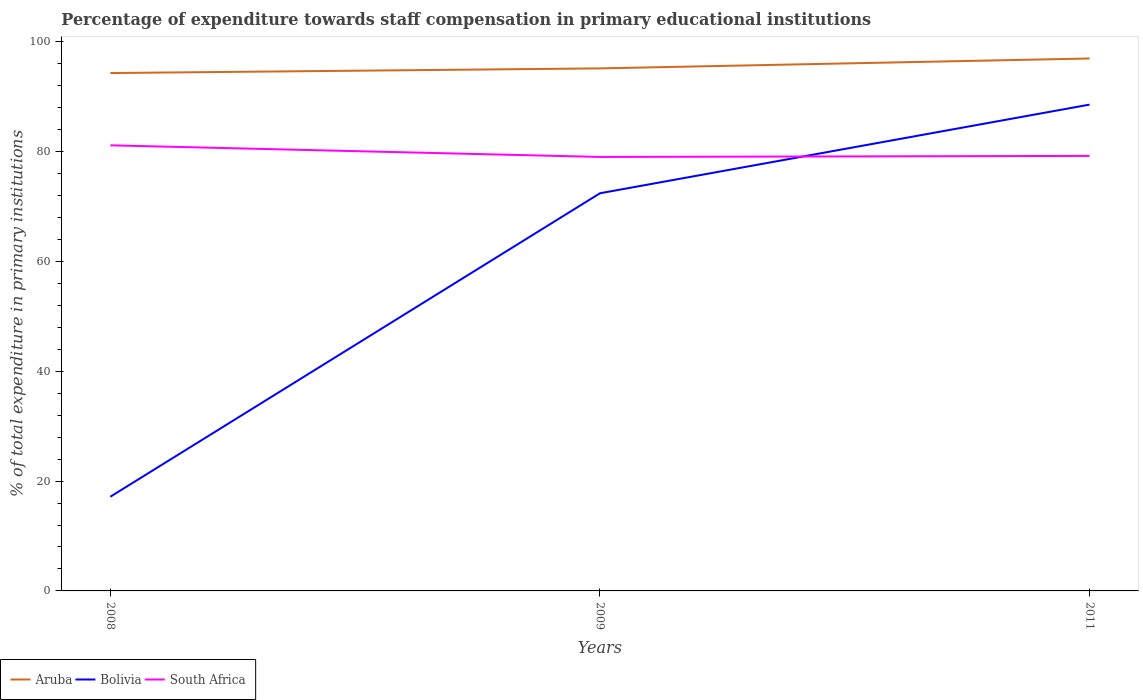How many different coloured lines are there?
Provide a succinct answer. 3. Across all years, what is the maximum percentage of expenditure towards staff compensation in Aruba?
Offer a very short reply. 94.3. In which year was the percentage of expenditure towards staff compensation in South Africa maximum?
Make the answer very short. 2009. What is the total percentage of expenditure towards staff compensation in Bolivia in the graph?
Your response must be concise. -71.4. What is the difference between the highest and the second highest percentage of expenditure towards staff compensation in South Africa?
Your answer should be very brief. 2.12. What is the difference between the highest and the lowest percentage of expenditure towards staff compensation in Aruba?
Offer a terse response. 1. Is the percentage of expenditure towards staff compensation in Bolivia strictly greater than the percentage of expenditure towards staff compensation in Aruba over the years?
Your response must be concise. Yes. How many lines are there?
Your answer should be compact. 3. How many years are there in the graph?
Provide a short and direct response. 3. What is the difference between two consecutive major ticks on the Y-axis?
Your answer should be very brief. 20. Does the graph contain grids?
Your answer should be compact. No. What is the title of the graph?
Your response must be concise. Percentage of expenditure towards staff compensation in primary educational institutions. Does "Qatar" appear as one of the legend labels in the graph?
Provide a short and direct response. No. What is the label or title of the X-axis?
Your answer should be very brief. Years. What is the label or title of the Y-axis?
Give a very brief answer. % of total expenditure in primary institutions. What is the % of total expenditure in primary institutions in Aruba in 2008?
Your answer should be very brief. 94.3. What is the % of total expenditure in primary institutions in Bolivia in 2008?
Your response must be concise. 17.15. What is the % of total expenditure in primary institutions of South Africa in 2008?
Give a very brief answer. 81.14. What is the % of total expenditure in primary institutions of Aruba in 2009?
Your answer should be compact. 95.15. What is the % of total expenditure in primary institutions in Bolivia in 2009?
Your response must be concise. 72.41. What is the % of total expenditure in primary institutions of South Africa in 2009?
Make the answer very short. 79.03. What is the % of total expenditure in primary institutions of Aruba in 2011?
Ensure brevity in your answer.  96.95. What is the % of total expenditure in primary institutions of Bolivia in 2011?
Keep it short and to the point. 88.55. What is the % of total expenditure in primary institutions of South Africa in 2011?
Your response must be concise. 79.21. Across all years, what is the maximum % of total expenditure in primary institutions in Aruba?
Your answer should be compact. 96.95. Across all years, what is the maximum % of total expenditure in primary institutions in Bolivia?
Offer a very short reply. 88.55. Across all years, what is the maximum % of total expenditure in primary institutions of South Africa?
Make the answer very short. 81.14. Across all years, what is the minimum % of total expenditure in primary institutions of Aruba?
Your answer should be very brief. 94.3. Across all years, what is the minimum % of total expenditure in primary institutions of Bolivia?
Your response must be concise. 17.15. Across all years, what is the minimum % of total expenditure in primary institutions of South Africa?
Give a very brief answer. 79.03. What is the total % of total expenditure in primary institutions of Aruba in the graph?
Your answer should be compact. 286.41. What is the total % of total expenditure in primary institutions in Bolivia in the graph?
Your answer should be compact. 178.12. What is the total % of total expenditure in primary institutions in South Africa in the graph?
Your answer should be compact. 239.38. What is the difference between the % of total expenditure in primary institutions of Aruba in 2008 and that in 2009?
Keep it short and to the point. -0.85. What is the difference between the % of total expenditure in primary institutions of Bolivia in 2008 and that in 2009?
Keep it short and to the point. -55.26. What is the difference between the % of total expenditure in primary institutions in South Africa in 2008 and that in 2009?
Keep it short and to the point. 2.12. What is the difference between the % of total expenditure in primary institutions of Aruba in 2008 and that in 2011?
Your answer should be very brief. -2.65. What is the difference between the % of total expenditure in primary institutions in Bolivia in 2008 and that in 2011?
Offer a very short reply. -71.4. What is the difference between the % of total expenditure in primary institutions in South Africa in 2008 and that in 2011?
Your answer should be compact. 1.93. What is the difference between the % of total expenditure in primary institutions of Aruba in 2009 and that in 2011?
Ensure brevity in your answer.  -1.8. What is the difference between the % of total expenditure in primary institutions of Bolivia in 2009 and that in 2011?
Your answer should be very brief. -16.14. What is the difference between the % of total expenditure in primary institutions in South Africa in 2009 and that in 2011?
Offer a very short reply. -0.19. What is the difference between the % of total expenditure in primary institutions in Aruba in 2008 and the % of total expenditure in primary institutions in Bolivia in 2009?
Give a very brief answer. 21.89. What is the difference between the % of total expenditure in primary institutions in Aruba in 2008 and the % of total expenditure in primary institutions in South Africa in 2009?
Provide a short and direct response. 15.28. What is the difference between the % of total expenditure in primary institutions of Bolivia in 2008 and the % of total expenditure in primary institutions of South Africa in 2009?
Ensure brevity in your answer.  -61.87. What is the difference between the % of total expenditure in primary institutions in Aruba in 2008 and the % of total expenditure in primary institutions in Bolivia in 2011?
Offer a terse response. 5.75. What is the difference between the % of total expenditure in primary institutions in Aruba in 2008 and the % of total expenditure in primary institutions in South Africa in 2011?
Your answer should be very brief. 15.09. What is the difference between the % of total expenditure in primary institutions in Bolivia in 2008 and the % of total expenditure in primary institutions in South Africa in 2011?
Keep it short and to the point. -62.06. What is the difference between the % of total expenditure in primary institutions in Aruba in 2009 and the % of total expenditure in primary institutions in Bolivia in 2011?
Give a very brief answer. 6.6. What is the difference between the % of total expenditure in primary institutions in Aruba in 2009 and the % of total expenditure in primary institutions in South Africa in 2011?
Your response must be concise. 15.94. What is the difference between the % of total expenditure in primary institutions in Bolivia in 2009 and the % of total expenditure in primary institutions in South Africa in 2011?
Offer a terse response. -6.8. What is the average % of total expenditure in primary institutions of Aruba per year?
Provide a succinct answer. 95.47. What is the average % of total expenditure in primary institutions in Bolivia per year?
Make the answer very short. 59.37. What is the average % of total expenditure in primary institutions of South Africa per year?
Offer a very short reply. 79.79. In the year 2008, what is the difference between the % of total expenditure in primary institutions in Aruba and % of total expenditure in primary institutions in Bolivia?
Keep it short and to the point. 77.15. In the year 2008, what is the difference between the % of total expenditure in primary institutions in Aruba and % of total expenditure in primary institutions in South Africa?
Offer a very short reply. 13.16. In the year 2008, what is the difference between the % of total expenditure in primary institutions of Bolivia and % of total expenditure in primary institutions of South Africa?
Your answer should be very brief. -63.99. In the year 2009, what is the difference between the % of total expenditure in primary institutions in Aruba and % of total expenditure in primary institutions in Bolivia?
Offer a very short reply. 22.74. In the year 2009, what is the difference between the % of total expenditure in primary institutions in Aruba and % of total expenditure in primary institutions in South Africa?
Offer a terse response. 16.13. In the year 2009, what is the difference between the % of total expenditure in primary institutions in Bolivia and % of total expenditure in primary institutions in South Africa?
Your response must be concise. -6.61. In the year 2011, what is the difference between the % of total expenditure in primary institutions of Aruba and % of total expenditure in primary institutions of Bolivia?
Your answer should be very brief. 8.4. In the year 2011, what is the difference between the % of total expenditure in primary institutions in Aruba and % of total expenditure in primary institutions in South Africa?
Provide a succinct answer. 17.74. In the year 2011, what is the difference between the % of total expenditure in primary institutions of Bolivia and % of total expenditure in primary institutions of South Africa?
Your answer should be very brief. 9.34. What is the ratio of the % of total expenditure in primary institutions of Bolivia in 2008 to that in 2009?
Your answer should be very brief. 0.24. What is the ratio of the % of total expenditure in primary institutions of South Africa in 2008 to that in 2009?
Give a very brief answer. 1.03. What is the ratio of the % of total expenditure in primary institutions of Aruba in 2008 to that in 2011?
Make the answer very short. 0.97. What is the ratio of the % of total expenditure in primary institutions in Bolivia in 2008 to that in 2011?
Your response must be concise. 0.19. What is the ratio of the % of total expenditure in primary institutions in South Africa in 2008 to that in 2011?
Your answer should be compact. 1.02. What is the ratio of the % of total expenditure in primary institutions of Aruba in 2009 to that in 2011?
Your answer should be very brief. 0.98. What is the ratio of the % of total expenditure in primary institutions of Bolivia in 2009 to that in 2011?
Your answer should be compact. 0.82. What is the ratio of the % of total expenditure in primary institutions in South Africa in 2009 to that in 2011?
Offer a terse response. 1. What is the difference between the highest and the second highest % of total expenditure in primary institutions in Aruba?
Ensure brevity in your answer.  1.8. What is the difference between the highest and the second highest % of total expenditure in primary institutions of Bolivia?
Keep it short and to the point. 16.14. What is the difference between the highest and the second highest % of total expenditure in primary institutions in South Africa?
Offer a terse response. 1.93. What is the difference between the highest and the lowest % of total expenditure in primary institutions in Aruba?
Your answer should be very brief. 2.65. What is the difference between the highest and the lowest % of total expenditure in primary institutions of Bolivia?
Make the answer very short. 71.4. What is the difference between the highest and the lowest % of total expenditure in primary institutions in South Africa?
Provide a short and direct response. 2.12. 